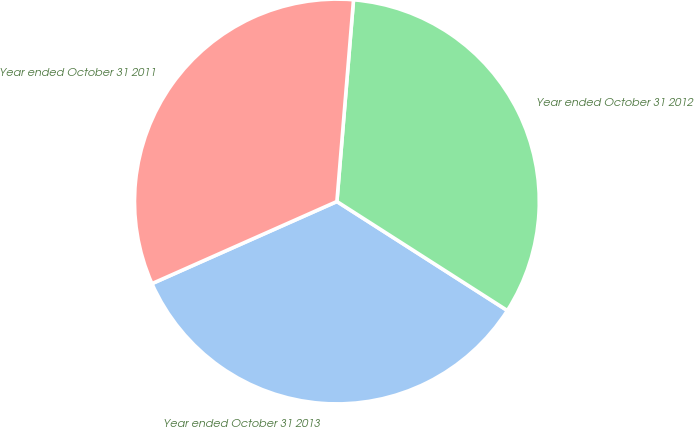Convert chart. <chart><loc_0><loc_0><loc_500><loc_500><pie_chart><fcel>Year ended October 31 2013<fcel>Year ended October 31 2012<fcel>Year ended October 31 2011<nl><fcel>34.29%<fcel>32.75%<fcel>32.96%<nl></chart> 